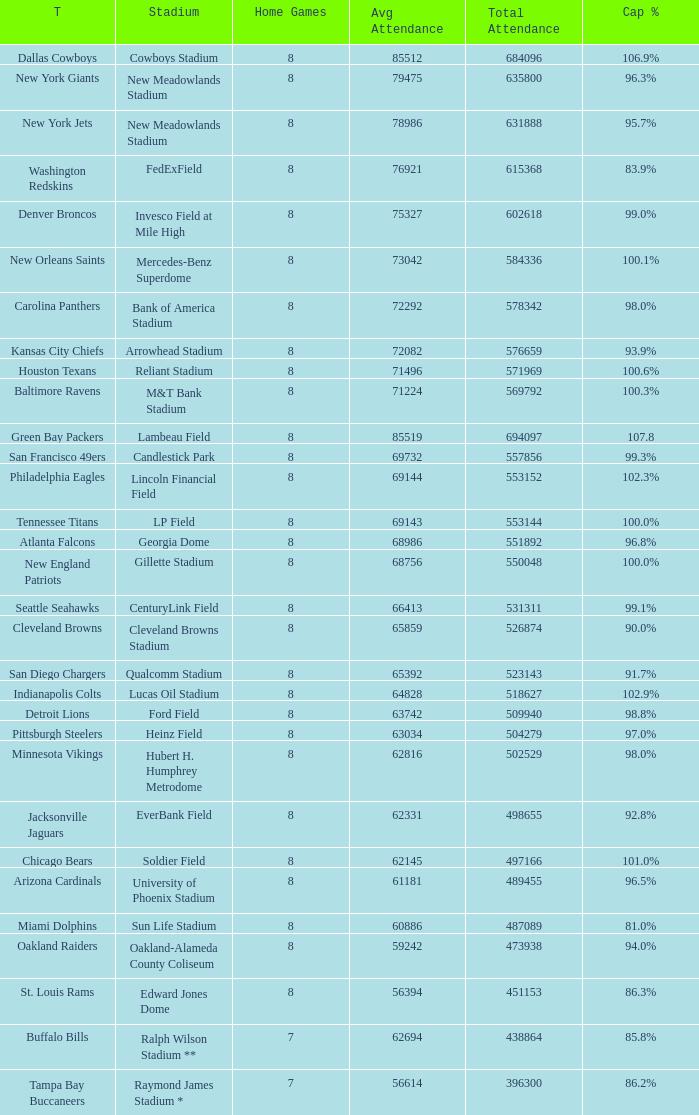How many average attendance has a capacity percentage of 96.5% 1.0. Can you parse all the data within this table? {'header': ['T', 'Stadium', 'Home Games', 'Avg Attendance', 'Total Attendance', 'Cap %'], 'rows': [['Dallas Cowboys', 'Cowboys Stadium', '8', '85512', '684096', '106.9%'], ['New York Giants', 'New Meadowlands Stadium', '8', '79475', '635800', '96.3%'], ['New York Jets', 'New Meadowlands Stadium', '8', '78986', '631888', '95.7%'], ['Washington Redskins', 'FedExField', '8', '76921', '615368', '83.9%'], ['Denver Broncos', 'Invesco Field at Mile High', '8', '75327', '602618', '99.0%'], ['New Orleans Saints', 'Mercedes-Benz Superdome', '8', '73042', '584336', '100.1%'], ['Carolina Panthers', 'Bank of America Stadium', '8', '72292', '578342', '98.0%'], ['Kansas City Chiefs', 'Arrowhead Stadium', '8', '72082', '576659', '93.9%'], ['Houston Texans', 'Reliant Stadium', '8', '71496', '571969', '100.6%'], ['Baltimore Ravens', 'M&T Bank Stadium', '8', '71224', '569792', '100.3%'], ['Green Bay Packers', 'Lambeau Field', '8', '85519', '694097', '107.8'], ['San Francisco 49ers', 'Candlestick Park', '8', '69732', '557856', '99.3%'], ['Philadelphia Eagles', 'Lincoln Financial Field', '8', '69144', '553152', '102.3%'], ['Tennessee Titans', 'LP Field', '8', '69143', '553144', '100.0%'], ['Atlanta Falcons', 'Georgia Dome', '8', '68986', '551892', '96.8%'], ['New England Patriots', 'Gillette Stadium', '8', '68756', '550048', '100.0%'], ['Seattle Seahawks', 'CenturyLink Field', '8', '66413', '531311', '99.1%'], ['Cleveland Browns', 'Cleveland Browns Stadium', '8', '65859', '526874', '90.0%'], ['San Diego Chargers', 'Qualcomm Stadium', '8', '65392', '523143', '91.7%'], ['Indianapolis Colts', 'Lucas Oil Stadium', '8', '64828', '518627', '102.9%'], ['Detroit Lions', 'Ford Field', '8', '63742', '509940', '98.8%'], ['Pittsburgh Steelers', 'Heinz Field', '8', '63034', '504279', '97.0%'], ['Minnesota Vikings', 'Hubert H. Humphrey Metrodome', '8', '62816', '502529', '98.0%'], ['Jacksonville Jaguars', 'EverBank Field', '8', '62331', '498655', '92.8%'], ['Chicago Bears', 'Soldier Field', '8', '62145', '497166', '101.0%'], ['Arizona Cardinals', 'University of Phoenix Stadium', '8', '61181', '489455', '96.5%'], ['Miami Dolphins', 'Sun Life Stadium', '8', '60886', '487089', '81.0%'], ['Oakland Raiders', 'Oakland-Alameda County Coliseum', '8', '59242', '473938', '94.0%'], ['St. Louis Rams', 'Edward Jones Dome', '8', '56394', '451153', '86.3%'], ['Buffalo Bills', 'Ralph Wilson Stadium **', '7', '62694', '438864', '85.8%'], ['Tampa Bay Buccaneers', 'Raymond James Stadium *', '7', '56614', '396300', '86.2%']]} 